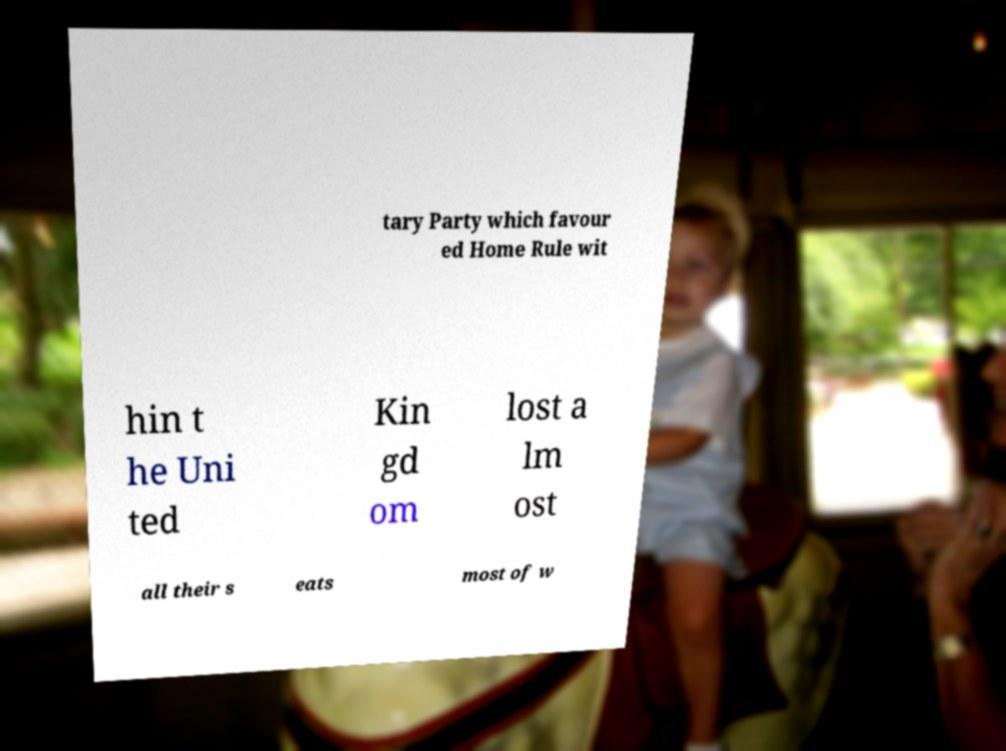Please read and relay the text visible in this image. What does it say? tary Party which favour ed Home Rule wit hin t he Uni ted Kin gd om lost a lm ost all their s eats most of w 